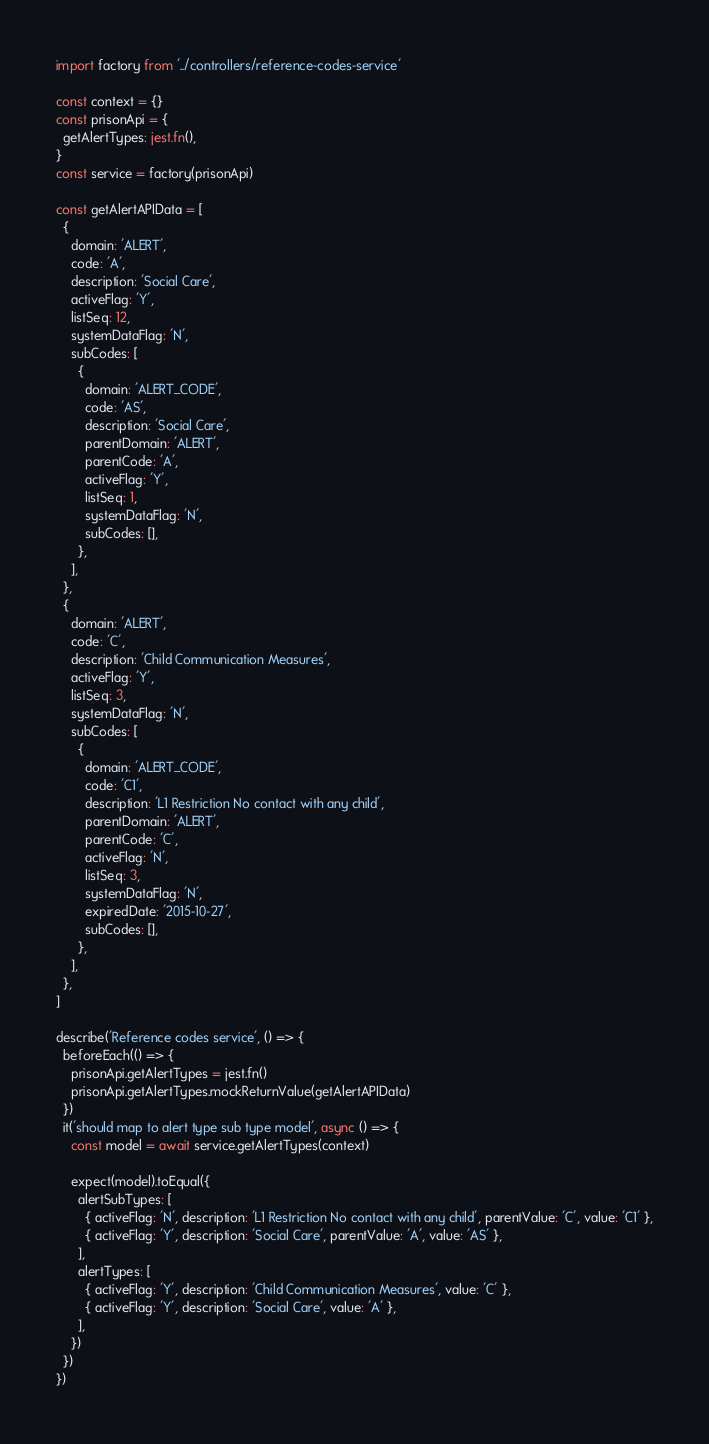Convert code to text. <code><loc_0><loc_0><loc_500><loc_500><_TypeScript_>import factory from '../controllers/reference-codes-service'

const context = {}
const prisonApi = {
  getAlertTypes: jest.fn(),
}
const service = factory(prisonApi)

const getAlertAPIData = [
  {
    domain: 'ALERT',
    code: 'A',
    description: 'Social Care',
    activeFlag: 'Y',
    listSeq: 12,
    systemDataFlag: 'N',
    subCodes: [
      {
        domain: 'ALERT_CODE',
        code: 'AS',
        description: 'Social Care',
        parentDomain: 'ALERT',
        parentCode: 'A',
        activeFlag: 'Y',
        listSeq: 1,
        systemDataFlag: 'N',
        subCodes: [],
      },
    ],
  },
  {
    domain: 'ALERT',
    code: 'C',
    description: 'Child Communication Measures',
    activeFlag: 'Y',
    listSeq: 3,
    systemDataFlag: 'N',
    subCodes: [
      {
        domain: 'ALERT_CODE',
        code: 'C1',
        description: 'L1 Restriction No contact with any child',
        parentDomain: 'ALERT',
        parentCode: 'C',
        activeFlag: 'N',
        listSeq: 3,
        systemDataFlag: 'N',
        expiredDate: '2015-10-27',
        subCodes: [],
      },
    ],
  },
]

describe('Reference codes service', () => {
  beforeEach(() => {
    prisonApi.getAlertTypes = jest.fn()
    prisonApi.getAlertTypes.mockReturnValue(getAlertAPIData)
  })
  it('should map to alert type sub type model', async () => {
    const model = await service.getAlertTypes(context)

    expect(model).toEqual({
      alertSubTypes: [
        { activeFlag: 'N', description: 'L1 Restriction No contact with any child', parentValue: 'C', value: 'C1' },
        { activeFlag: 'Y', description: 'Social Care', parentValue: 'A', value: 'AS' },
      ],
      alertTypes: [
        { activeFlag: 'Y', description: 'Child Communication Measures', value: 'C' },
        { activeFlag: 'Y', description: 'Social Care', value: 'A' },
      ],
    })
  })
})
</code> 